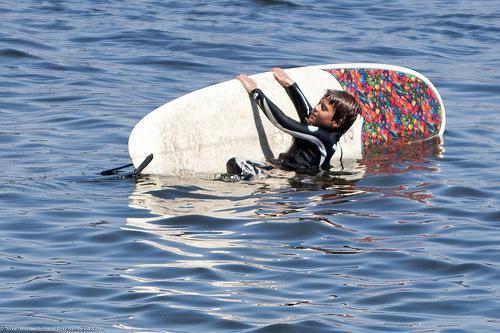How many people are in the image?
Give a very brief answer. 1. 